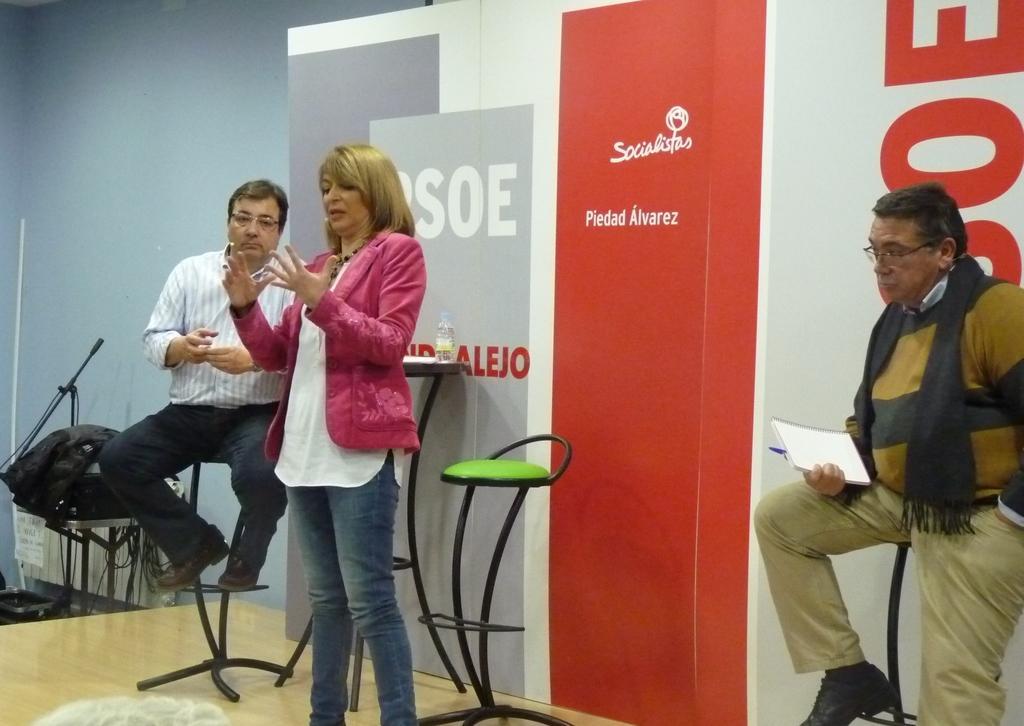Please provide a concise description of this image. This is a picture taken in a room, there are three people on the stage two men's are sitting on the chair and the women is standing and explaining something. Background of this people is a banner the banner is in the color of white and red. 